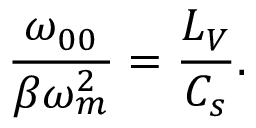Convert formula to latex. <formula><loc_0><loc_0><loc_500><loc_500>\frac { \omega _ { 0 0 } } { \beta \omega _ { m } ^ { 2 } } = \frac { L _ { V } } { C _ { s } } .</formula> 